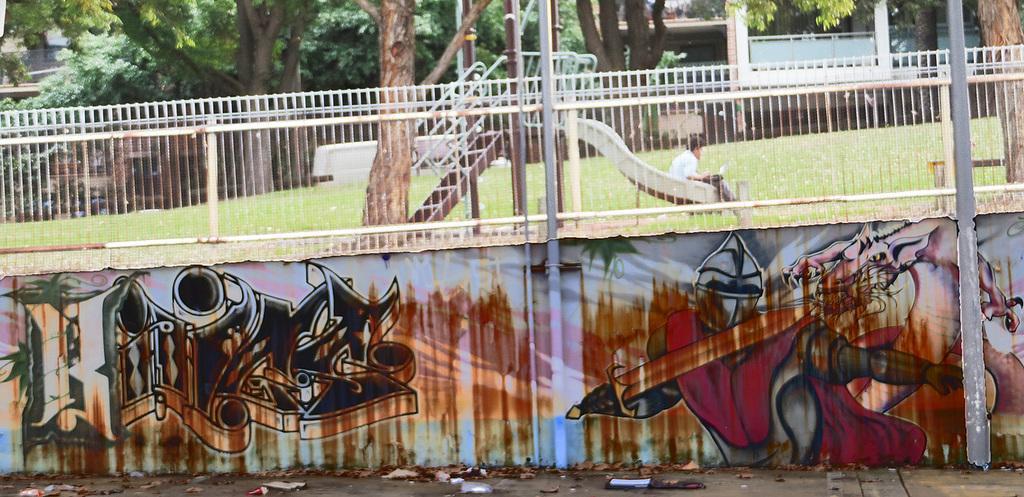Describe this image in one or two sentences. This image is taken outdoors. At the bottom of the image there is a road. In the middle of the image there is a wall with a graffiti and a railing. There is a ground with grass on it and there is a slide. In the background there are a few trees and there is a bench and a boy is sitting on the slide. 